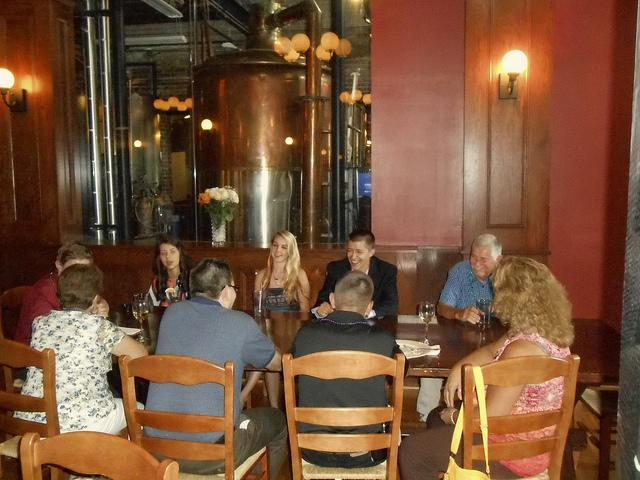What is the equipment in the background used for?

Choices:
A) relaxation
B) heat
C) filtration
D) brewing brewing 